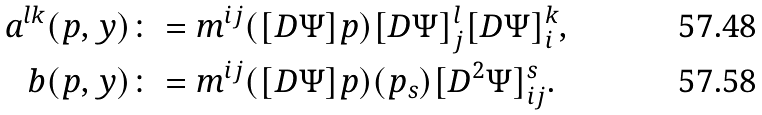<formula> <loc_0><loc_0><loc_500><loc_500>a ^ { l k } ( p , y ) \colon & = m ^ { i j } ( [ D \Psi ] p ) [ D \Psi ] ^ { l } _ { j } [ D \Psi ] ^ { k } _ { i } , \\ b ( p , y ) \colon & = m ^ { i j } ( [ D \Psi ] p ) ( p _ { s } ) [ D ^ { 2 } \Psi ] ^ { s } _ { i j } .</formula> 